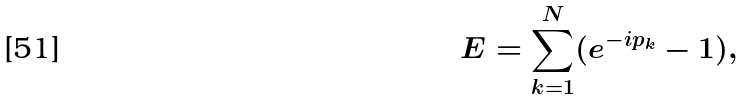<formula> <loc_0><loc_0><loc_500><loc_500>E = \sum _ { k = 1 } ^ { N } ( e ^ { - i p _ { k } } - 1 ) ,</formula> 